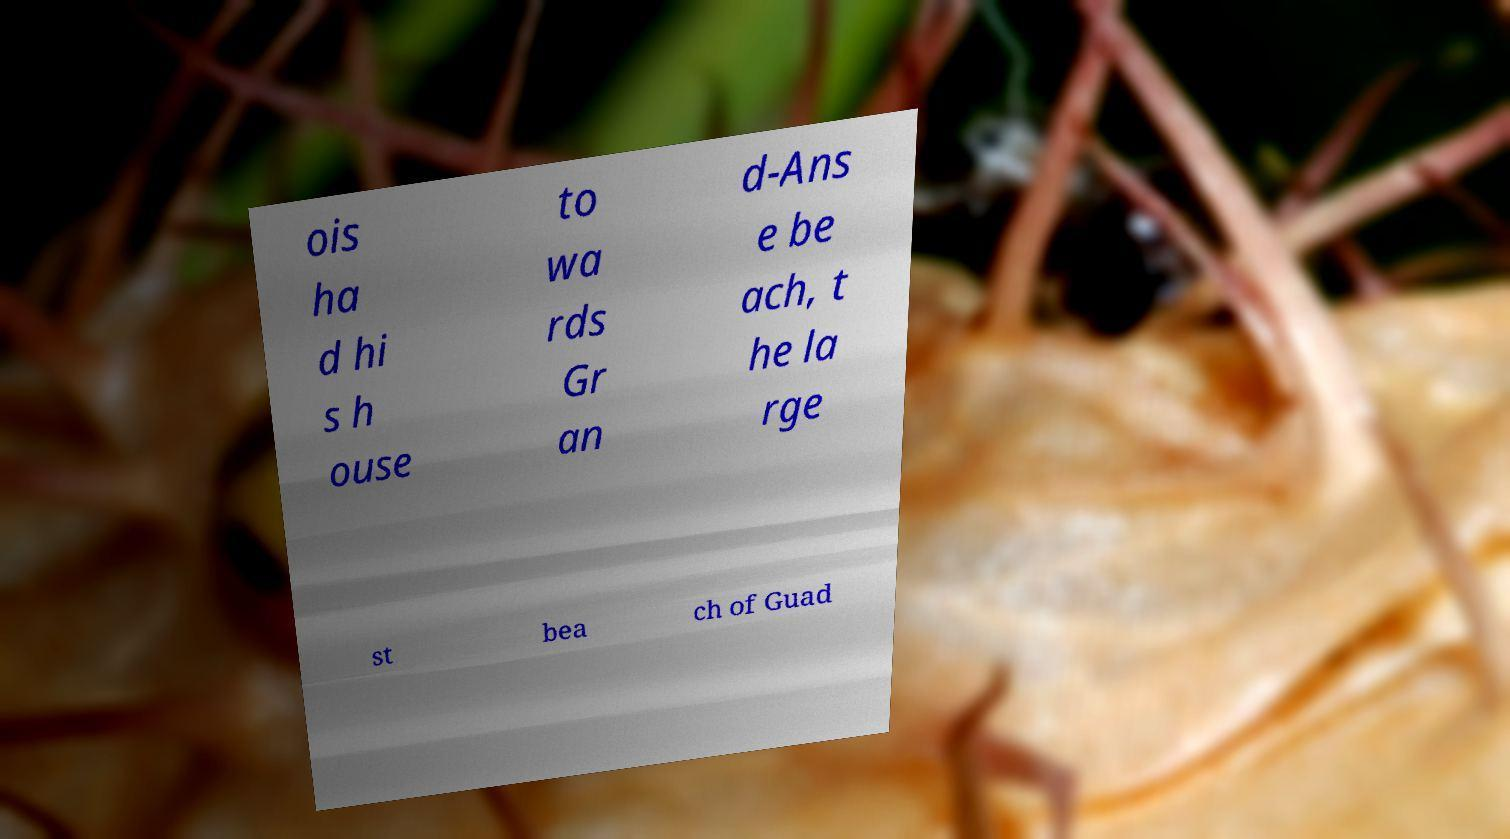There's text embedded in this image that I need extracted. Can you transcribe it verbatim? ois ha d hi s h ouse to wa rds Gr an d-Ans e be ach, t he la rge st bea ch of Guad 